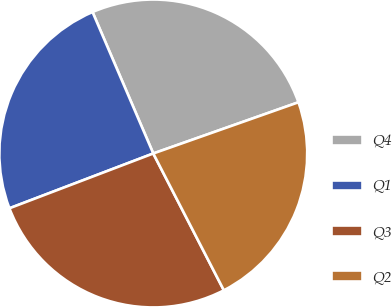Convert chart to OTSL. <chart><loc_0><loc_0><loc_500><loc_500><pie_chart><fcel>Q4<fcel>Q1<fcel>Q3<fcel>Q2<nl><fcel>26.06%<fcel>24.34%<fcel>26.79%<fcel>22.82%<nl></chart> 